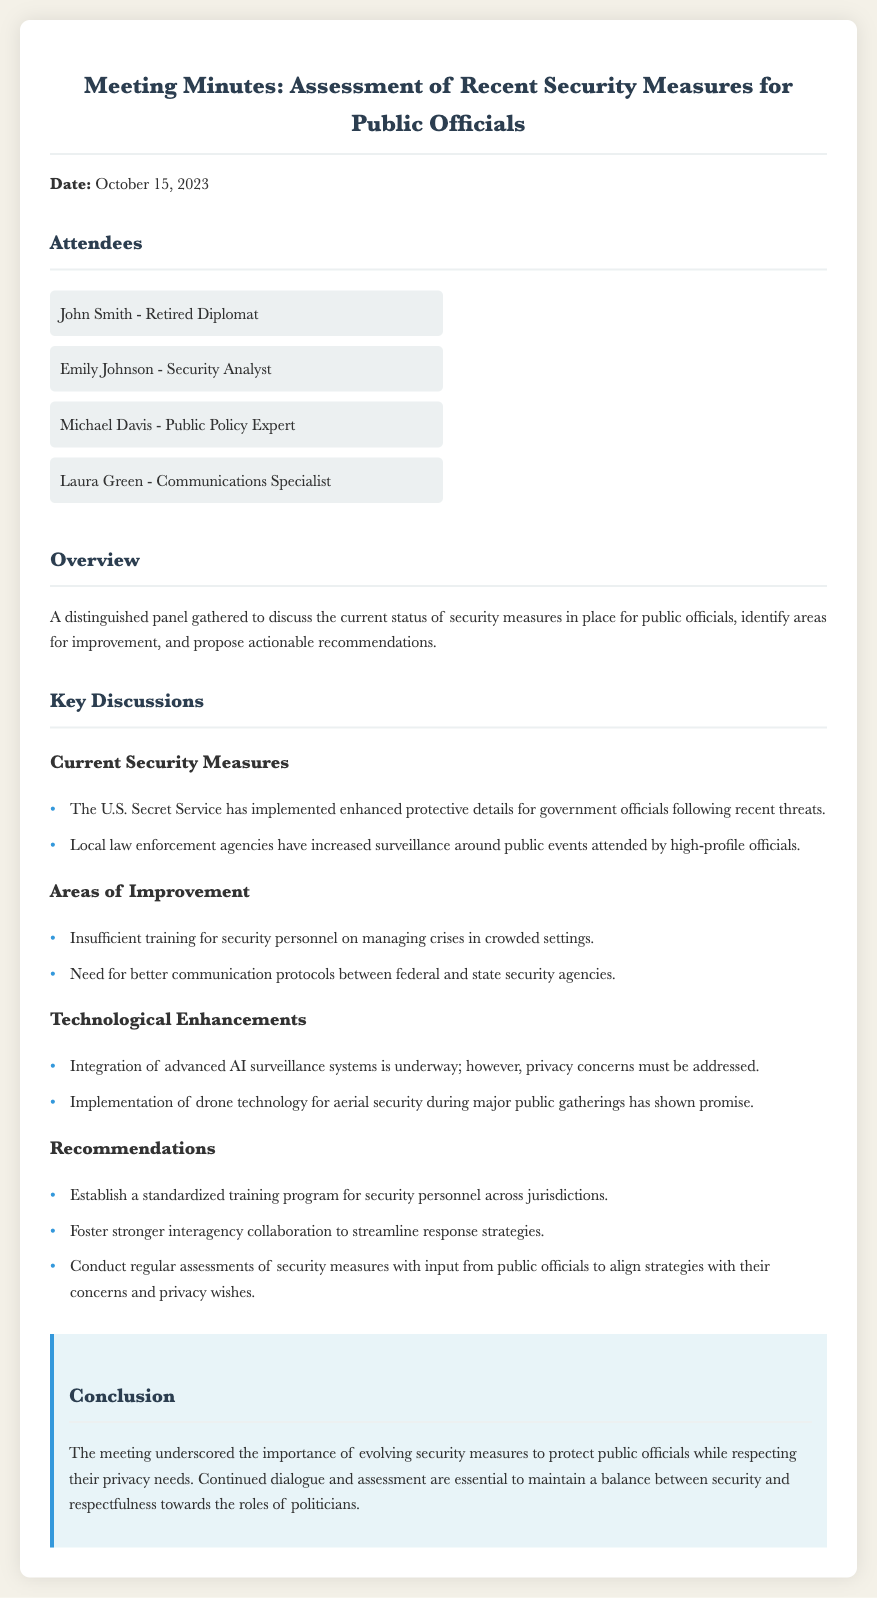What is the date of the meeting? The date of the meeting is stated at the beginning of the document.
Answer: October 15, 2023 Who is the security analyst present at the meeting? The attendees section lists individuals and their titles.
Answer: Emily Johnson What are the two areas identified for improvement? The document lists specific areas under the "Areas of Improvement" section.
Answer: Insufficient training and communication protocols What technology is mentioned for aerial security? The document refers to technology used for security during public gatherings.
Answer: Drone technology What is one of the recommendations made concerning security personnel? The recommendations section outlines specific suggestions for improvement.
Answer: Standardized training program How many attendees are mentioned in the document? The number of attendees can be counted in the attendees section.
Answer: Four What is the main focus of the meeting? The overview provides a clear statement of the meeting's purpose.
Answer: Assessment of recent security measures What is a key concern regarding AI surveillance systems? The document mentions privacy concerns related to technological enhancements.
Answer: Privacy concerns 